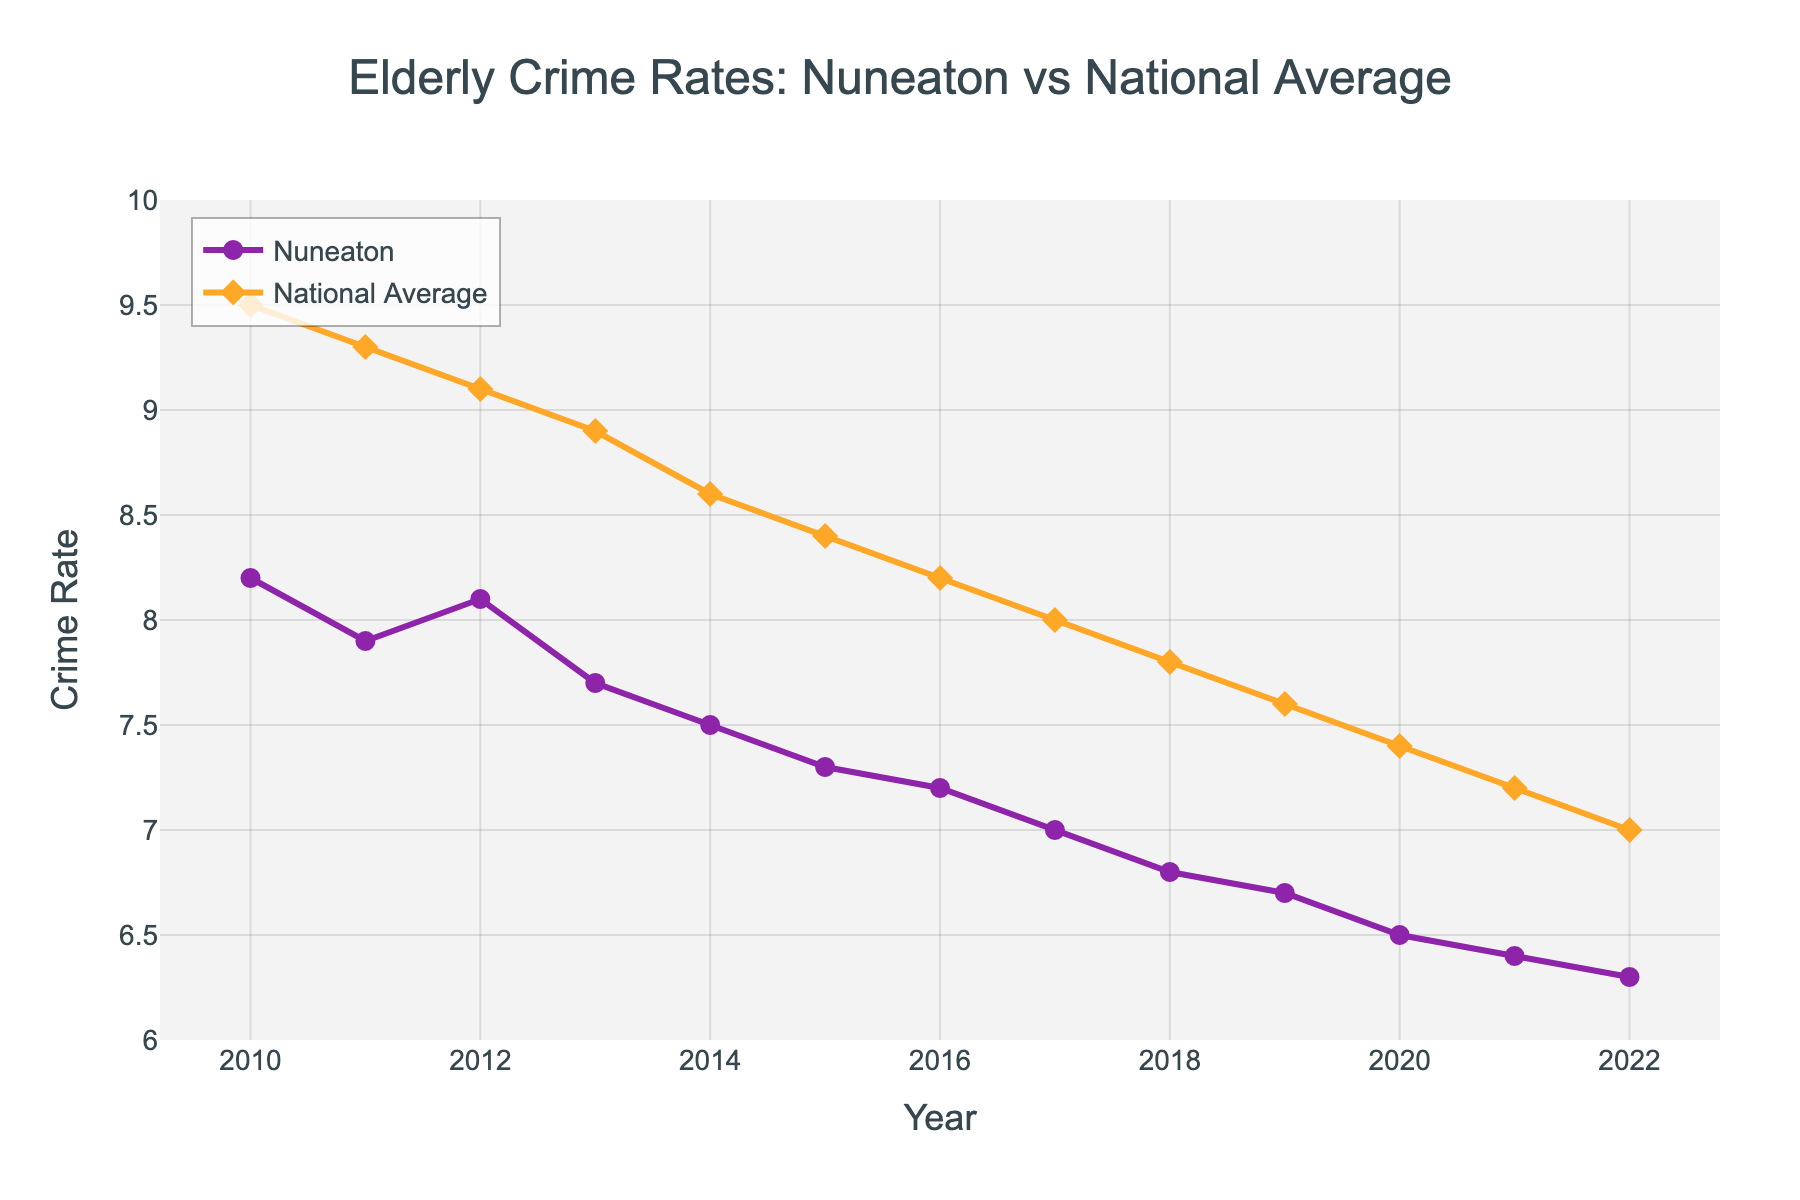what's the trend of elderly crime rates in Nuneaton from 2010 to 2022? From the line chart, the Nuneaton Elderly Crime Rate consistently decreases from 8.2 in 2010 to 6.3 in 2022.
Answer: Decreasing what's the difference in crime rates for the elderly between Nuneaton and the national average in 2010? In 2010, the Nuneaton Elderly Crime Rate is 8.2 and the National Elderly Crime Rate is 9.5. The difference is 9.5 - 8.2 = 1.3.
Answer: 1.3 how many years did Nuneaton's elderly crime rate fall below 7? The Nuneaton Elderly Crime Rate falls below 7 from 2017 to 2022, which is a total of 6 years.
Answer: 6 years is there any year when the elderly crime rate in Nuneaton was higher than the national average? By examining the lines on the chart, the Nuneaton Elderly Crime Rate is never higher than the National Elderly Crime Rate in any year from 2010 to 2022.
Answer: No which year had the smallest gap between Nuneaton and the national average elderly crime rates? The smallest gap occurs in 2022. The Nuneaton Elderly Crime Rate is 6.3 and the National Elderly Crime Rate is 7.0. The difference is 7.0 - 6.3 = 0.7.
Answer: 2022 calculate the average elderly crime rate in Nuneaton over the years 2010 to 2022 Adding the rates (8.2 + 7.9 + 8.1 + 7.7 + 7.5 + 7.3 + 7.2 + 7.0 + 6.8 + 6.7 + 6.5 + 6.4 + 6.3) and dividing by 13 gives an average of (93.6 / 13 = 7.2).
Answer: 7.2 What visual color is used to represent the national average elderly crime rate? The national average elderly crime rate is represented by an orange line with diamond markers.
Answer: Orange 